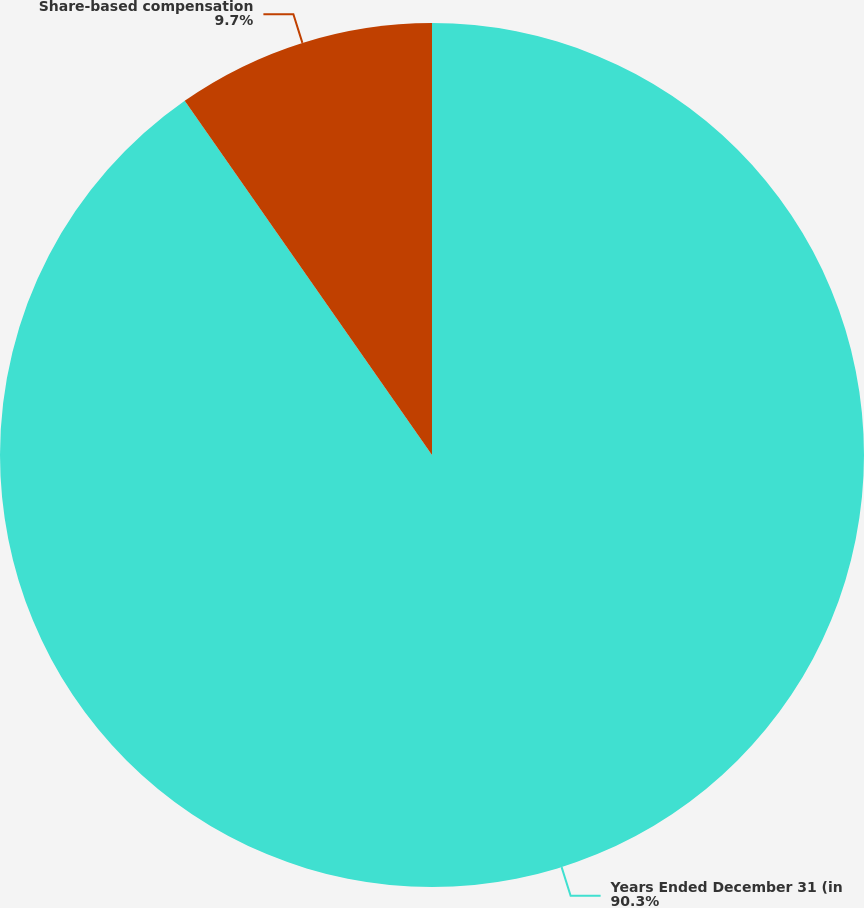Convert chart to OTSL. <chart><loc_0><loc_0><loc_500><loc_500><pie_chart><fcel>Years Ended December 31 (in<fcel>Share-based compensation<nl><fcel>90.3%<fcel>9.7%<nl></chart> 